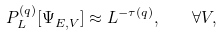Convert formula to latex. <formula><loc_0><loc_0><loc_500><loc_500>P ^ { ( q ) } _ { L } [ \Psi ^ { \ } _ { E , V } ] \approx L ^ { - \tau ( q ) } , \quad \forall V ,</formula> 